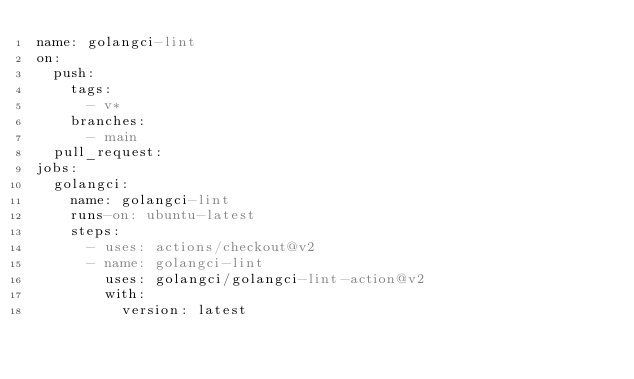<code> <loc_0><loc_0><loc_500><loc_500><_YAML_>name: golangci-lint
on:
  push:
    tags:
      - v*
    branches:
      - main
  pull_request:
jobs:
  golangci:
    name: golangci-lint
    runs-on: ubuntu-latest
    steps:
      - uses: actions/checkout@v2
      - name: golangci-lint
        uses: golangci/golangci-lint-action@v2
        with:
          version: latest
</code> 